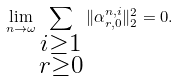<formula> <loc_0><loc_0><loc_500><loc_500>\lim _ { n \rightarrow \omega } \sum _ { \substack { i \geq 1 \\ r \geq 0 } } \| \alpha ^ { n , i } _ { r , 0 } \| _ { 2 } ^ { 2 } = 0 .</formula> 